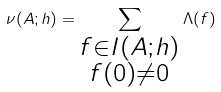<formula> <loc_0><loc_0><loc_500><loc_500>\nu ( A ; h ) = \sum _ { \substack { f \in I ( A ; h ) \\ f ( 0 ) \neq 0 } } \Lambda ( f )</formula> 